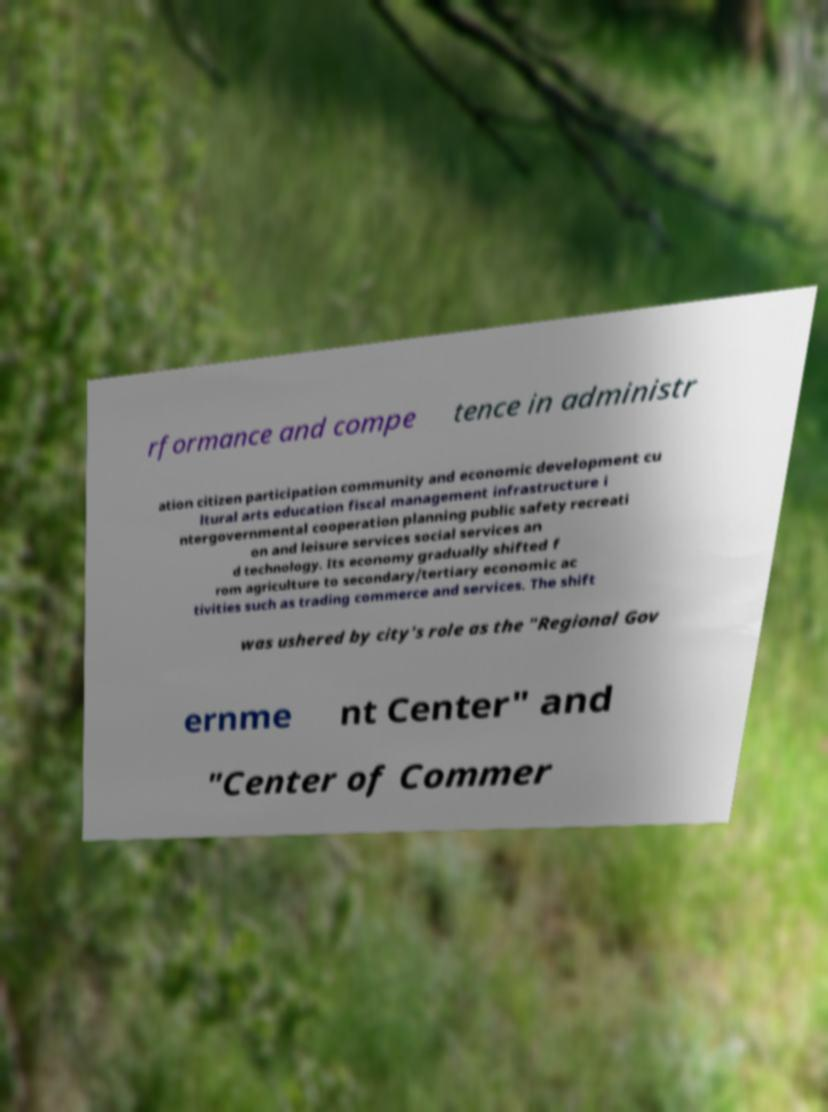Can you read and provide the text displayed in the image?This photo seems to have some interesting text. Can you extract and type it out for me? rformance and compe tence in administr ation citizen participation community and economic development cu ltural arts education fiscal management infrastructure i ntergovernmental cooperation planning public safety recreati on and leisure services social services an d technology. Its economy gradually shifted f rom agriculture to secondary/tertiary economic ac tivities such as trading commerce and services. The shift was ushered by city's role as the "Regional Gov ernme nt Center" and "Center of Commer 